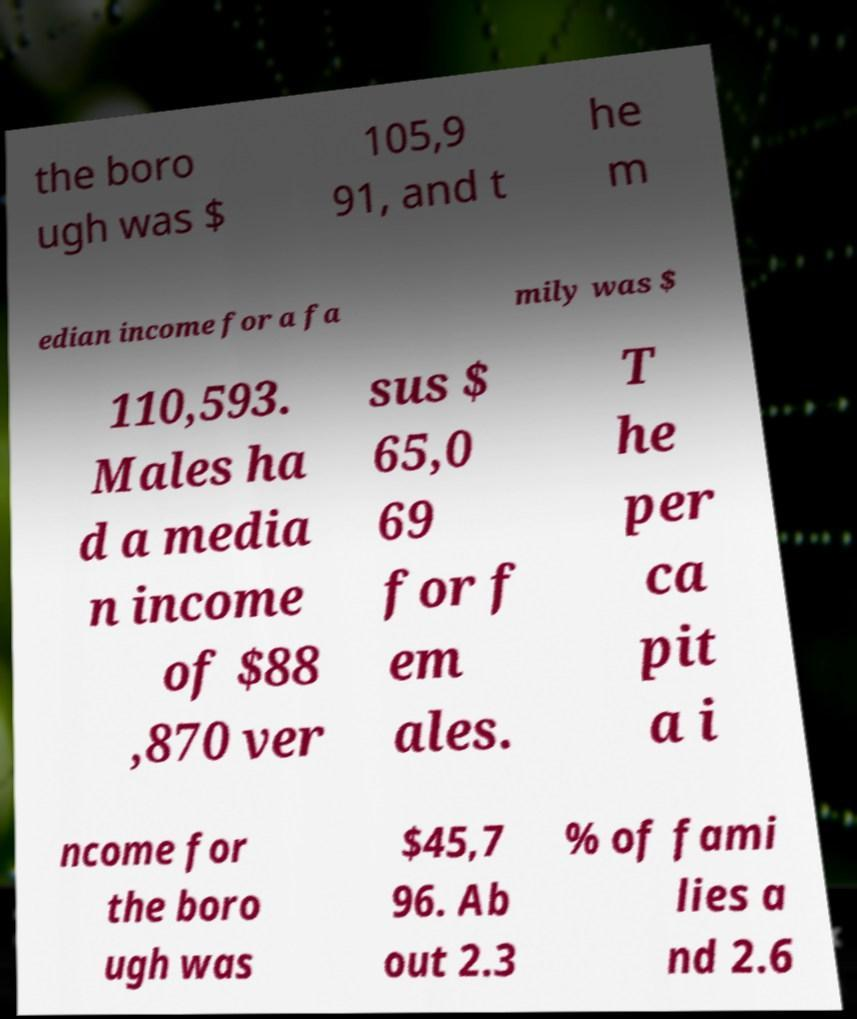Please identify and transcribe the text found in this image. the boro ugh was $ 105,9 91, and t he m edian income for a fa mily was $ 110,593. Males ha d a media n income of $88 ,870 ver sus $ 65,0 69 for f em ales. T he per ca pit a i ncome for the boro ugh was $45,7 96. Ab out 2.3 % of fami lies a nd 2.6 